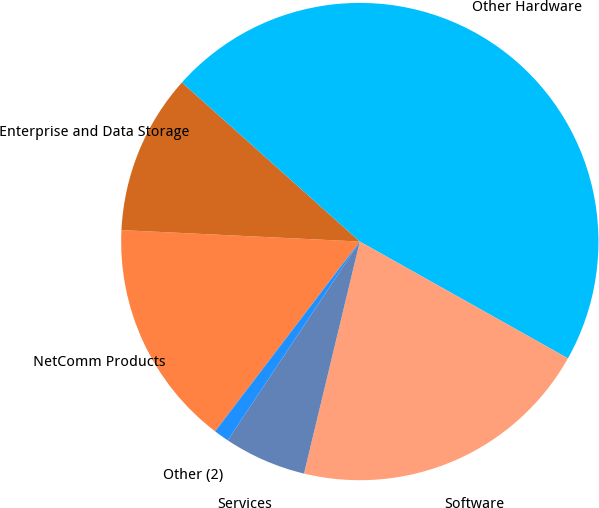Convert chart to OTSL. <chart><loc_0><loc_0><loc_500><loc_500><pie_chart><fcel>NetComm Products<fcel>Enterprise and Data Storage<fcel>Other Hardware<fcel>Software<fcel>Services<fcel>Other (2)<nl><fcel>15.4%<fcel>10.85%<fcel>46.53%<fcel>20.62%<fcel>5.58%<fcel>1.03%<nl></chart> 